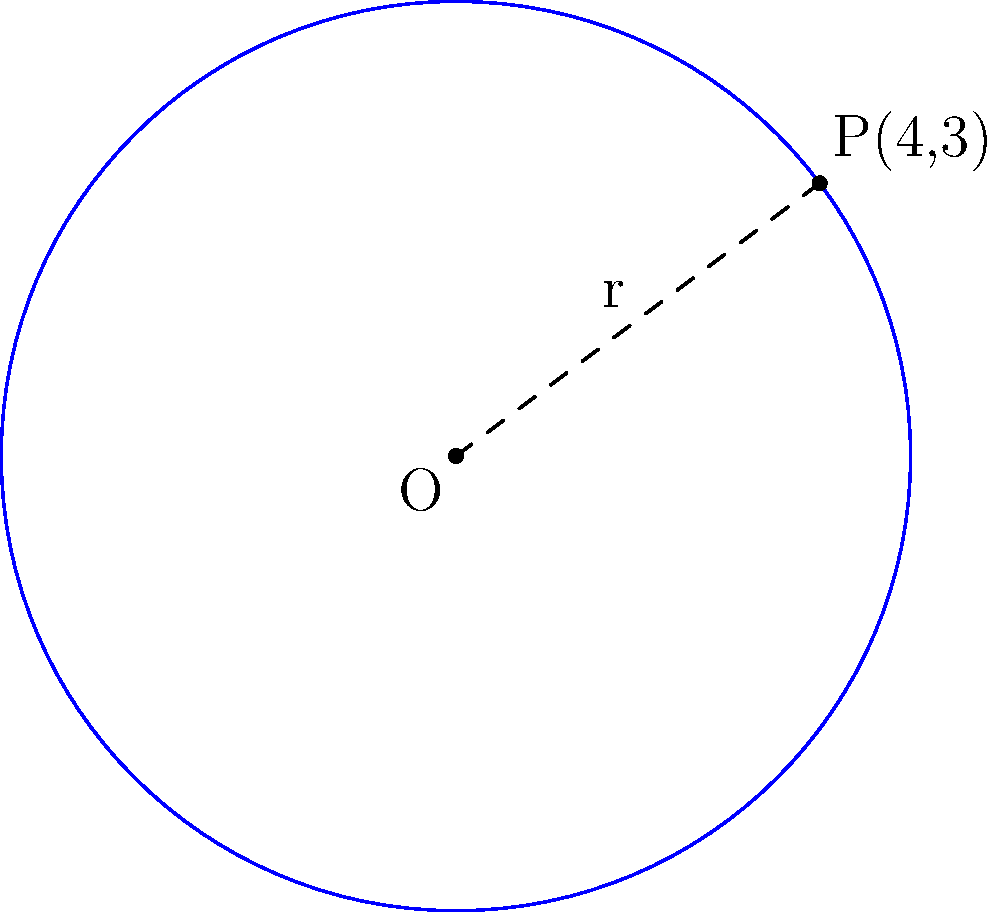As you document the agricultural traditions of the village, you come across a circular crop field. The elder explains that the center of the field is at the origin (0,0), and a point on its circumference is at (4,3). What is the perimeter of this circular field? To find the perimeter of the circular crop field, we need to follow these steps:

1) First, we need to calculate the radius of the circle. We can do this using the distance formula between the center (0,0) and the point on the circumference (4,3):

   $r = \sqrt{(x_2-x_1)^2 + (y_2-y_1)^2} = \sqrt{(4-0)^2 + (3-0)^2} = \sqrt{16 + 9} = \sqrt{25} = 5$

2) Now that we have the radius, we can calculate the perimeter (circumference) of the circle using the formula:

   $C = 2\pi r$

3) Substituting our radius value:

   $C = 2\pi(5) = 10\pi$

Therefore, the perimeter of the circular crop field is $10\pi$ units.
Answer: $10\pi$ units 